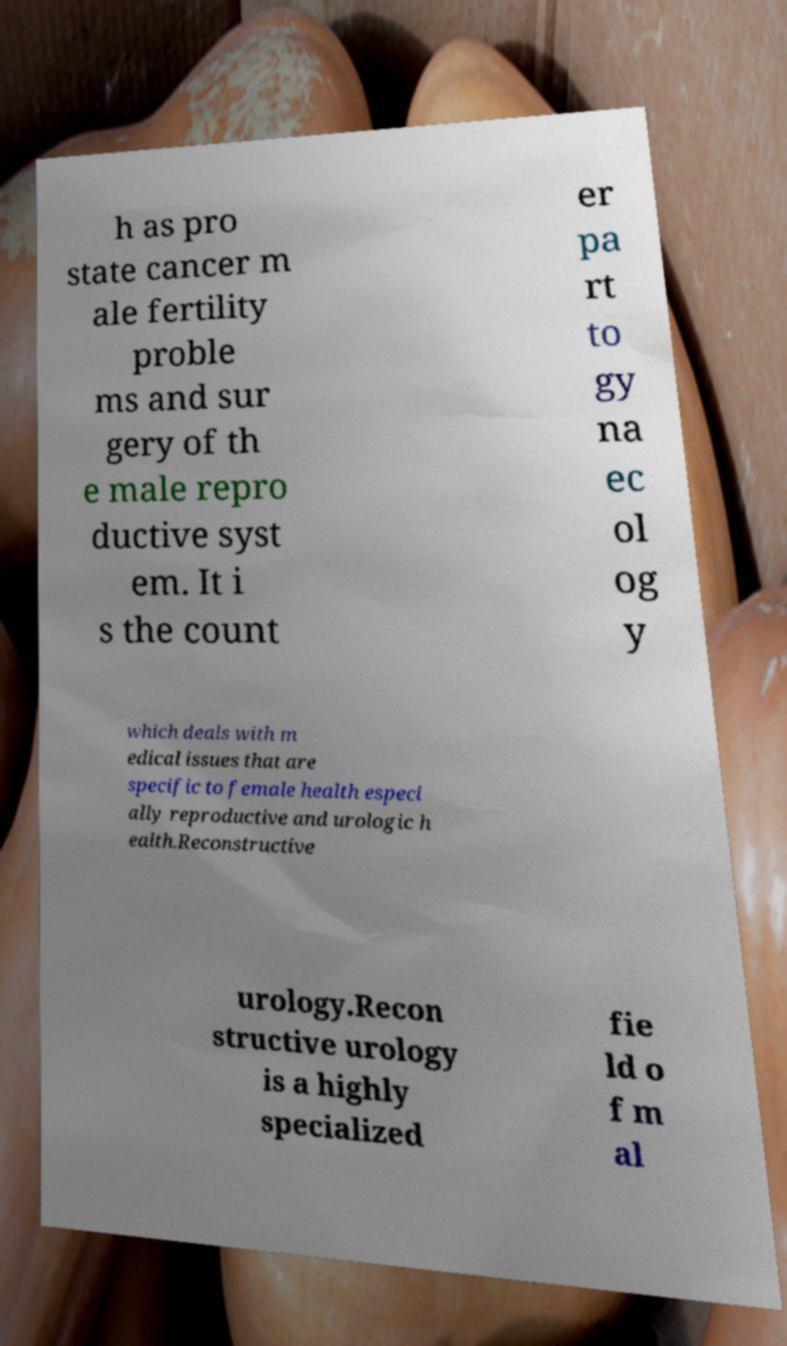Please identify and transcribe the text found in this image. h as pro state cancer m ale fertility proble ms and sur gery of th e male repro ductive syst em. It i s the count er pa rt to gy na ec ol og y which deals with m edical issues that are specific to female health especi ally reproductive and urologic h ealth.Reconstructive urology.Recon structive urology is a highly specialized fie ld o f m al 